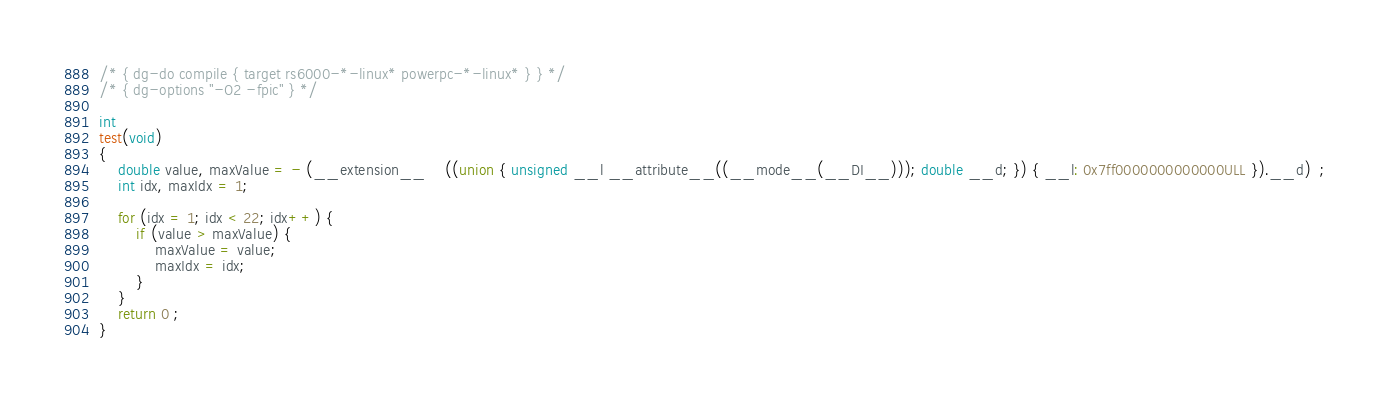<code> <loc_0><loc_0><loc_500><loc_500><_C_>/* { dg-do compile { target rs6000-*-linux* powerpc-*-linux* } } */
/* { dg-options "-O2 -fpic" } */

int
test(void)
{
    double value, maxValue = - (__extension__	((union { unsigned __l __attribute__((__mode__(__DI__))); double __d; }) { __l: 0x7ff0000000000000ULL }).__d)  ;
    int idx, maxIdx = 1;

    for (idx = 1; idx < 22; idx++) {
        if (value > maxValue) {
            maxValue = value;
            maxIdx = idx;
        }
    }
    return 0 ;
}
</code> 